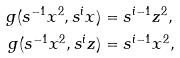Convert formula to latex. <formula><loc_0><loc_0><loc_500><loc_500>g ( s ^ { - 1 } x ^ { 2 } , s ^ { i } x ) & = s ^ { i - 1 } z ^ { 2 } , \\ g ( s ^ { - 1 } x ^ { 2 } , s ^ { i } z ) & = s ^ { i - 1 } x ^ { 2 } ,</formula> 